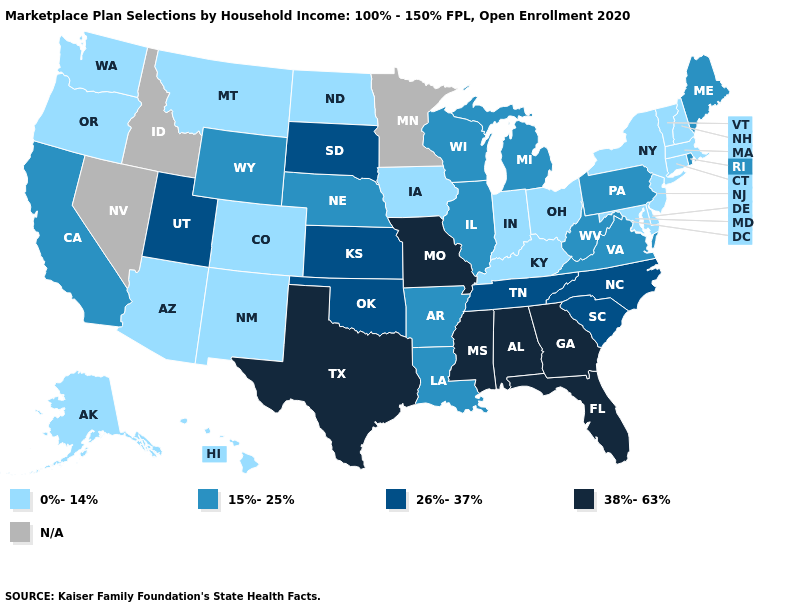What is the value of New Hampshire?
Be succinct. 0%-14%. Among the states that border Arizona , which have the lowest value?
Short answer required. Colorado, New Mexico. Name the states that have a value in the range N/A?
Answer briefly. Idaho, Minnesota, Nevada. What is the highest value in states that border Idaho?
Write a very short answer. 26%-37%. What is the lowest value in states that border New Hampshire?
Quick response, please. 0%-14%. What is the value of South Carolina?
Be succinct. 26%-37%. Name the states that have a value in the range 26%-37%?
Write a very short answer. Kansas, North Carolina, Oklahoma, South Carolina, South Dakota, Tennessee, Utah. What is the value of Georgia?
Write a very short answer. 38%-63%. What is the lowest value in the West?
Quick response, please. 0%-14%. Name the states that have a value in the range 15%-25%?
Keep it brief. Arkansas, California, Illinois, Louisiana, Maine, Michigan, Nebraska, Pennsylvania, Rhode Island, Virginia, West Virginia, Wisconsin, Wyoming. How many symbols are there in the legend?
Answer briefly. 5. How many symbols are there in the legend?
Answer briefly. 5. Which states have the lowest value in the MidWest?
Give a very brief answer. Indiana, Iowa, North Dakota, Ohio. What is the value of Tennessee?
Be succinct. 26%-37%. Which states hav the highest value in the MidWest?
Answer briefly. Missouri. 